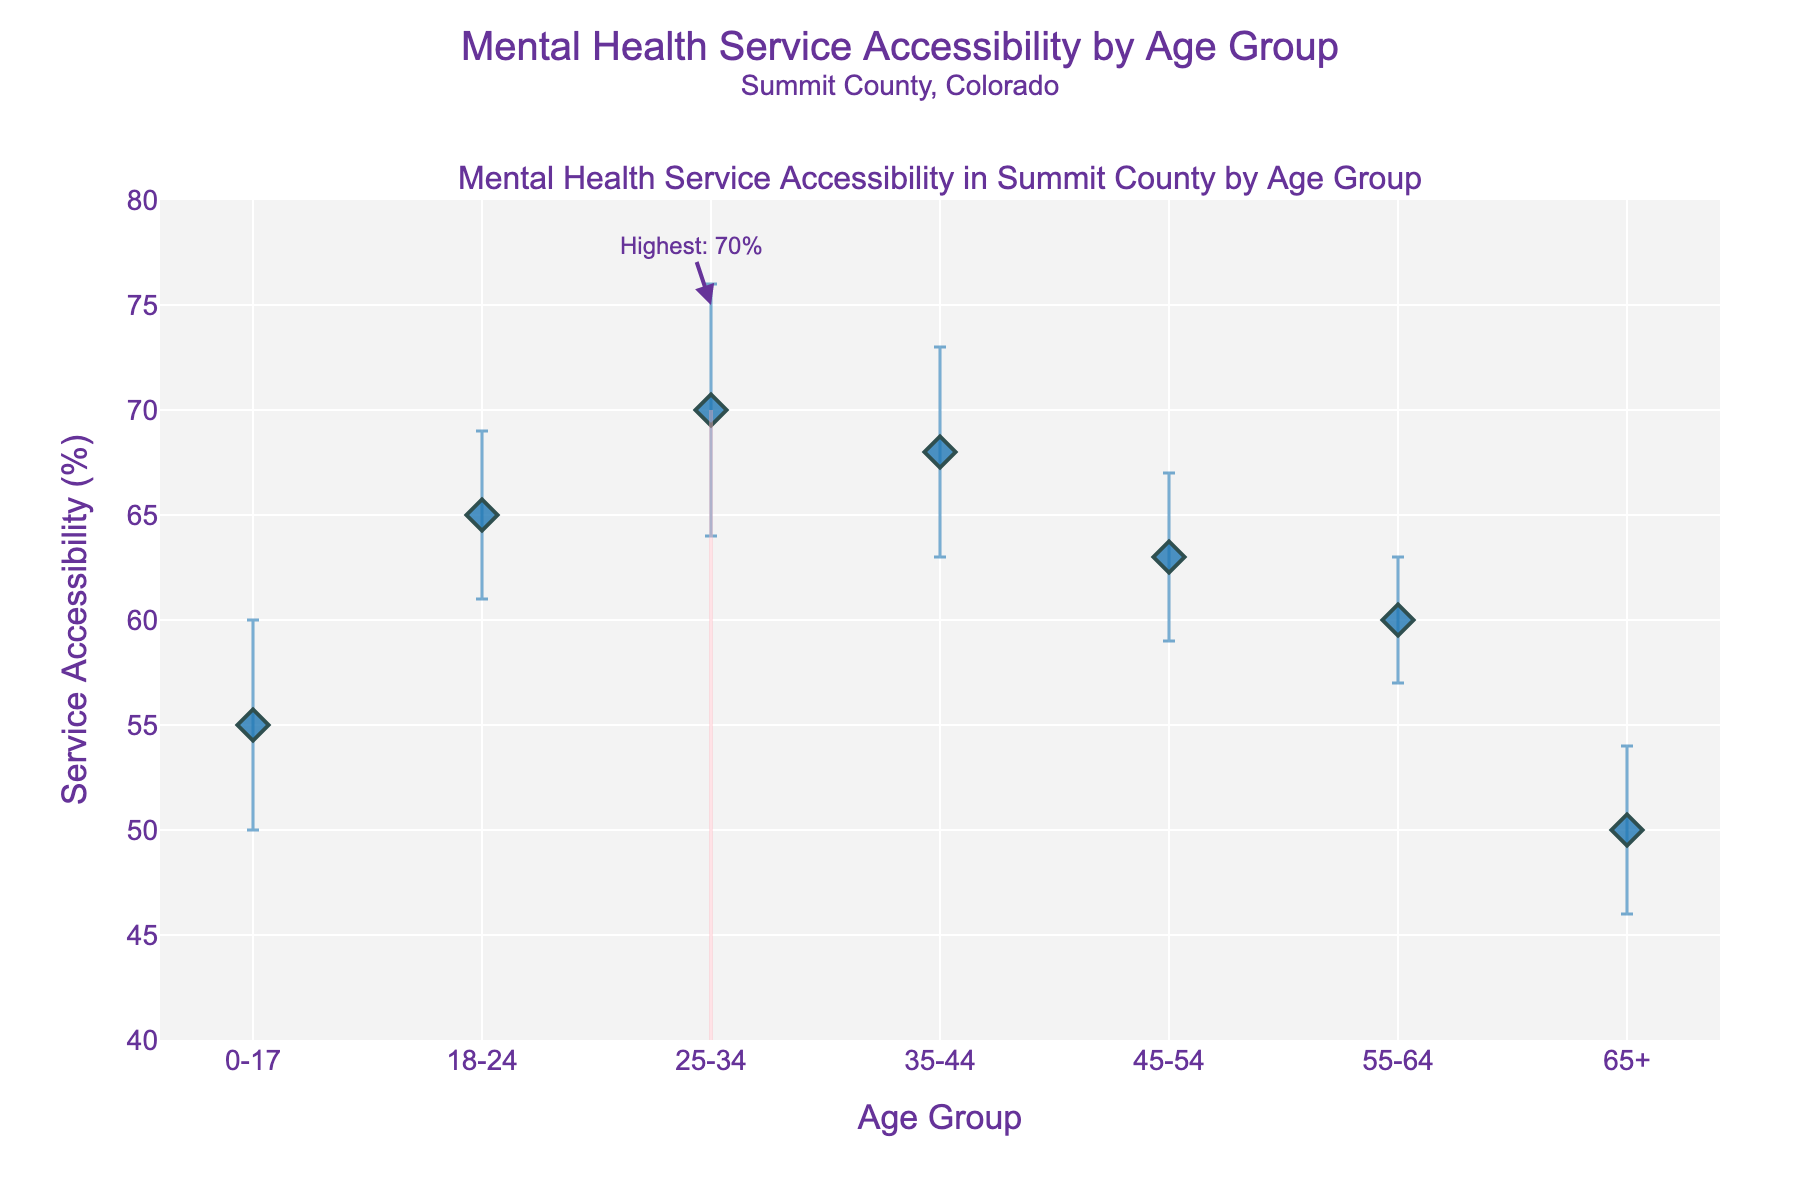What age group has the highest mental health service accessibility? The age group with the highest accessibility is highlighted with a rectangle and an annotation indicating "Highest: 70%". This refers to the 25-34 age group.
Answer: 25-34 What is the title of the figure? The title of the figure is displayed at the top and reads: "Mental Health Service Accessibility by Age Group, Summit County, Colorado".
Answer: Mental Health Service Accessibility by Age Group, Summit County, Colorado How does service accessibility change from the 18-24 age group to the 25-34 age group? By comparing the accessibility percentages, the 18-24 age group has 65%, while the 25-34 age group has 70%, indicating an increase of 5%.
Answer: Increases by 5% What is the approximate service accessibility percentage for the age group 55-64? By looking at the plot, the service accessibility for the age group 55-64 is approximately 60%.
Answer: 60% What is the range of y-axis values in the figure? The y-axis range is indicated by the axis ticks from 40% to 80%.
Answer: 40 to 80 Compare the error bars of the age groups 45-54 and 65+. Which age group has a smaller error? The error bars for the 45-54 age group are 4%, while for the 65+ age group, they are also 4%. Hence, they are equal.
Answer: Equal By how much does service accessibility for the 0-17 age group differ from the 65+ age group? Service accessibility for the 0-17 age group is 55%, and for the 65+ age group is 50%. The difference is 55% - 50% = 5%.
Answer: 5% What is the overall trend of service accessibility as age increases? The service accessibility percentage starts relatively high for the 0-17 age group, increases to peak at the 25-34 age group, and then generally decreases as age continues to increase.
Answer: Peaks at 25-34, then decreases Which age groups have a service accessibility error of 5%? By examining the error bars, the age groups 0-17 and 35-44 have an error of 5%.
Answer: 0-17, 35-44 What is the accessibility percentage for the age group 35-44? Looking at the plot, the accessibility for the age group 35-44 is recorded at 68%.
Answer: 68% 